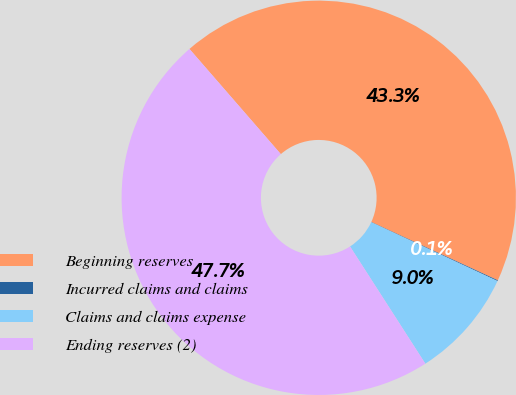Convert chart. <chart><loc_0><loc_0><loc_500><loc_500><pie_chart><fcel>Beginning reserves<fcel>Incurred claims and claims<fcel>Claims and claims expense<fcel>Ending reserves (2)<nl><fcel>43.26%<fcel>0.07%<fcel>8.97%<fcel>47.71%<nl></chart> 